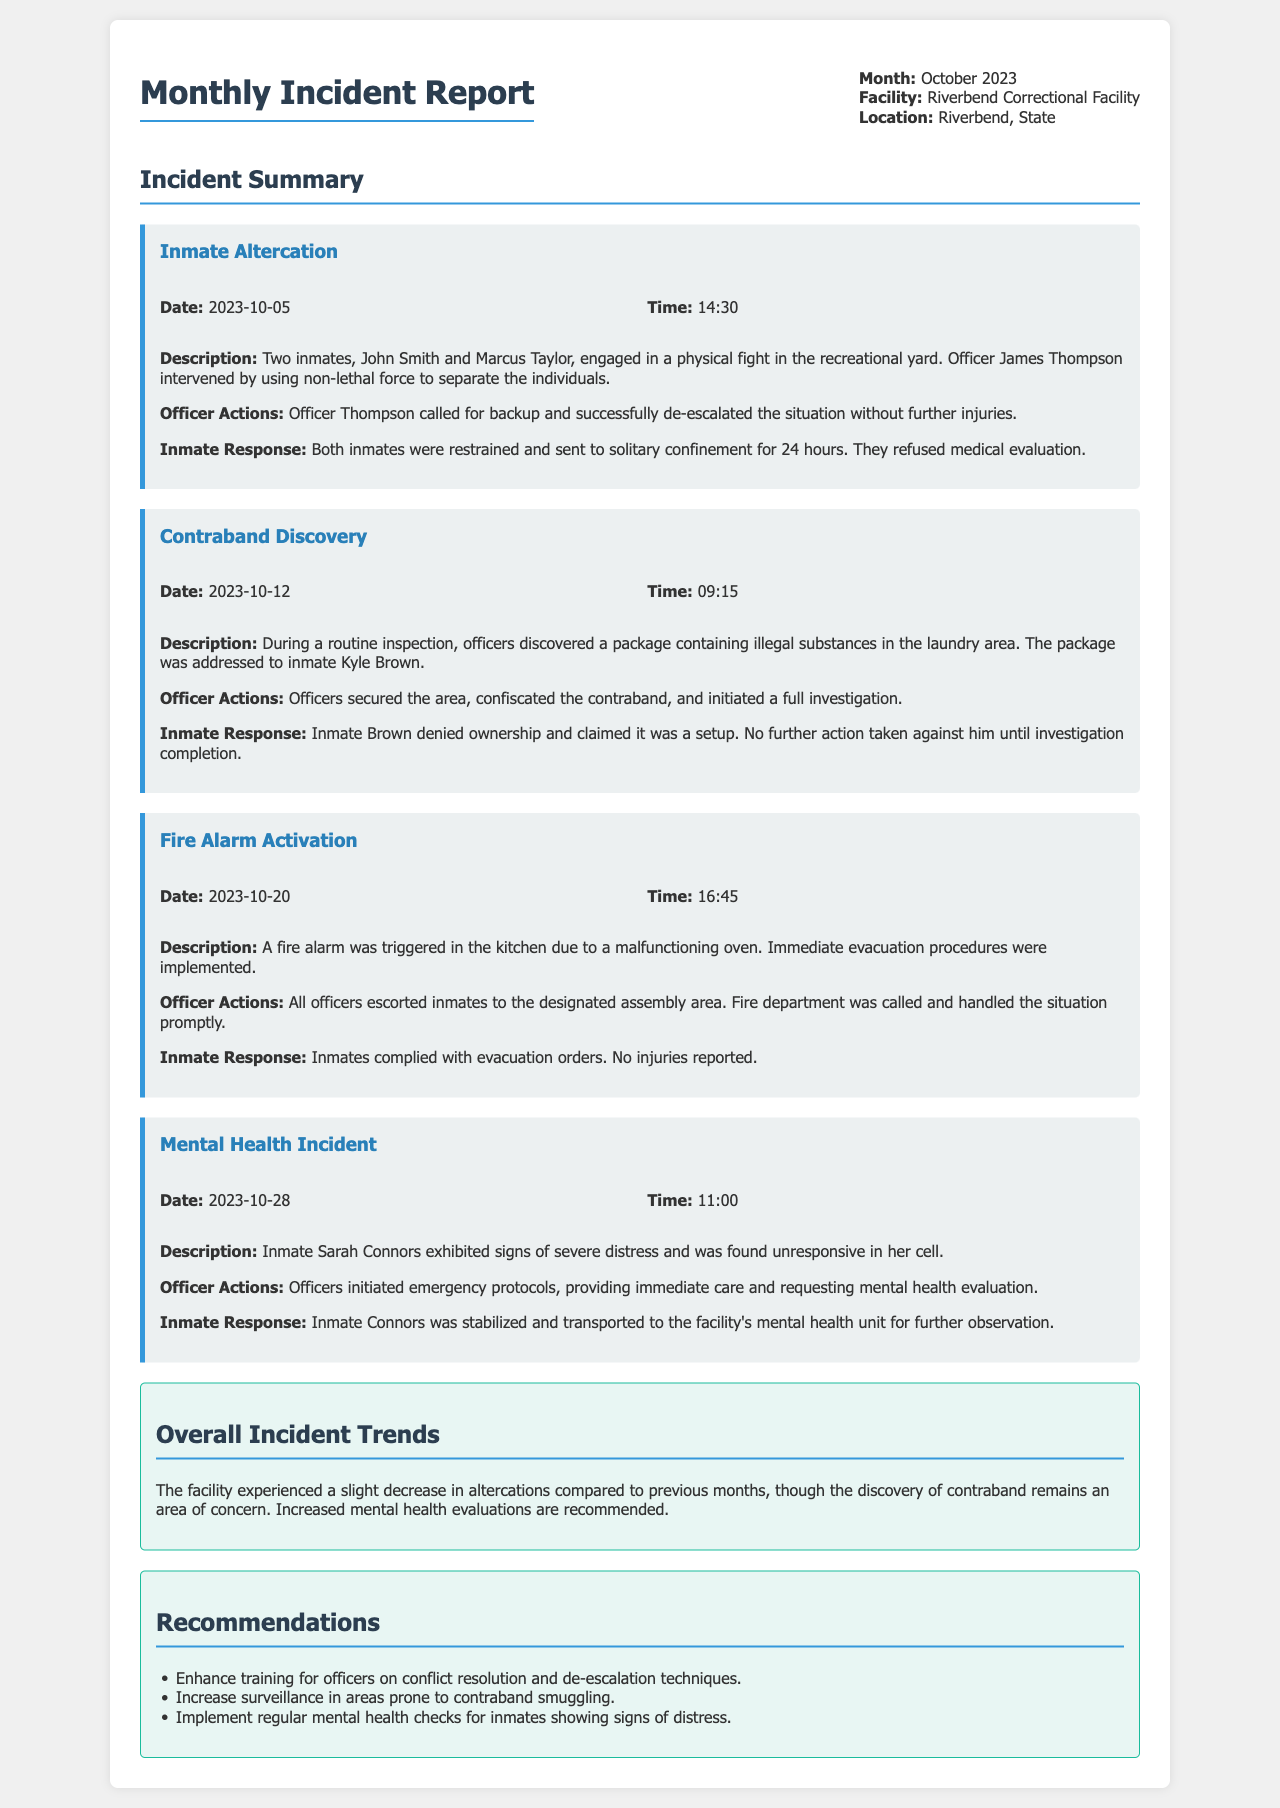What incident occurred on October 5, 2023? The incident on October 5, 2023, involved two inmates engaged in a physical fight in the recreational yard.
Answer: Inmate Altercation Who intervened during the inmate altercation? Officer Thompson intervened during the inmate altercation.
Answer: Officer James Thompson What time was the fire alarm triggered? The fire alarm was triggered at 16:45.
Answer: 16:45 What was discovered during the routine inspection on October 12, 2023? A package containing illegal substances was discovered during the inspection.
Answer: Contraband How did inmates respond to the fire alarm situation? Inmates complied with evacuation orders.
Answer: Complied What recommendations were made regarding mental health checks? The recommendation was to implement regular mental health checks for inmates showing signs of distress.
Answer: Regular mental health checks How many inmates were sent to solitary confinement following the altercation? Both inmates were sent to solitary confinement for 24 hours.
Answer: Two inmates What was the outcome for inmate Sarah Connors after the mental health incident? Inmate Connors was stabilized and transported to the facility's mental health unit.
Answer: Transported to mental health unit What was the main concern highlighted in the overall incident trends? The discovery of contraband remains an area of concern.
Answer: Contraband What was the date of the contraband discovery? The contraband discovery occurred on October 12, 2023.
Answer: October 12, 2023 